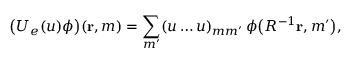<formula> <loc_0><loc_0><loc_500><loc_500>\left ( U _ { e } ( u ) \phi \right ) ( { r } , m ) = \sum _ { m ^ { \prime } } ( u \dots u ) _ { m m ^ { \prime } } \, \phi \left ( R ^ { - 1 } { r } , m ^ { \prime } \right ) ,</formula> 